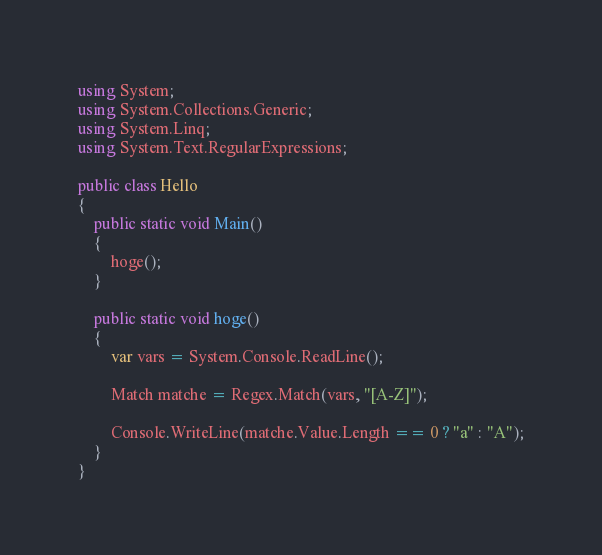<code> <loc_0><loc_0><loc_500><loc_500><_C#_>using System;
using System.Collections.Generic;
using System.Linq;
using System.Text.RegularExpressions;

public class Hello
{
    public static void Main()
    {
        hoge();
    }

    public static void hoge()
    {
        var vars = System.Console.ReadLine();

        Match matche = Regex.Match(vars, "[A-Z]");

        Console.WriteLine(matche.Value.Length == 0 ? "a" : "A");
    }
}</code> 